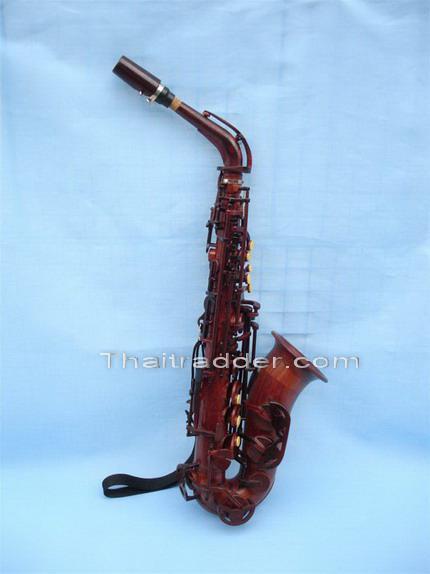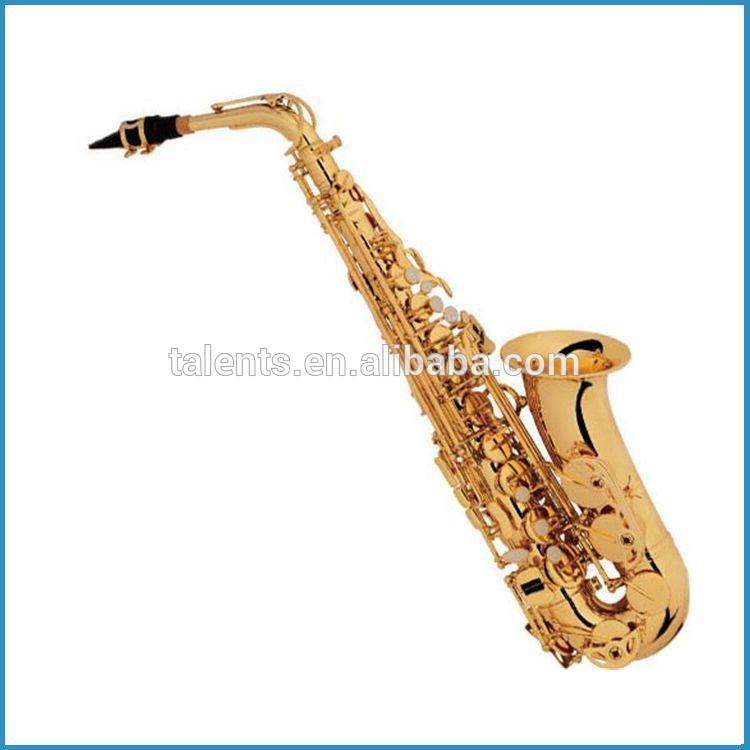The first image is the image on the left, the second image is the image on the right. Evaluate the accuracy of this statement regarding the images: "There are at least four instruments in total shown.". Is it true? Answer yes or no. No. 